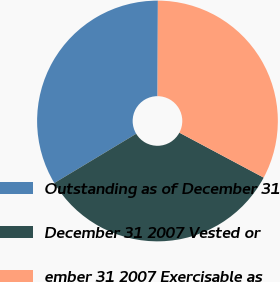Convert chart to OTSL. <chart><loc_0><loc_0><loc_500><loc_500><pie_chart><fcel>Outstanding as of December 31<fcel>December 31 2007 Vested or<fcel>ember 31 2007 Exercisable as<nl><fcel>33.67%<fcel>33.58%<fcel>32.74%<nl></chart> 